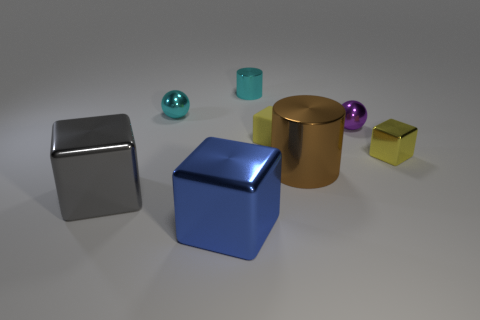How many yellow cubes must be subtracted to get 1 yellow cubes? 1 Subtract 1 blocks. How many blocks are left? 3 Add 2 big brown metal cylinders. How many objects exist? 10 Subtract all cylinders. How many objects are left? 6 Subtract all tiny balls. Subtract all tiny matte cubes. How many objects are left? 5 Add 8 gray metallic cubes. How many gray metallic cubes are left? 9 Add 6 large red matte cubes. How many large red matte cubes exist? 6 Subtract 0 green spheres. How many objects are left? 8 